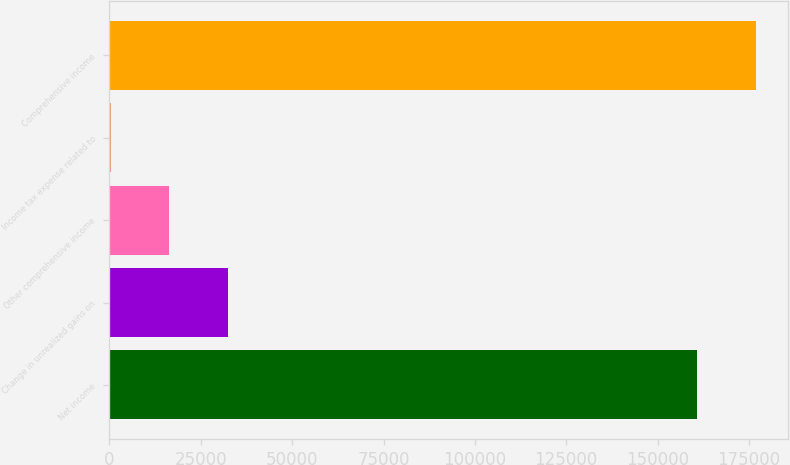Convert chart. <chart><loc_0><loc_0><loc_500><loc_500><bar_chart><fcel>Net income<fcel>Change in unrealized gains on<fcel>Other comprehensive income<fcel>Income tax expense related to<fcel>Comprehensive income<nl><fcel>160853<fcel>32522.8<fcel>16421.9<fcel>321<fcel>176954<nl></chart> 